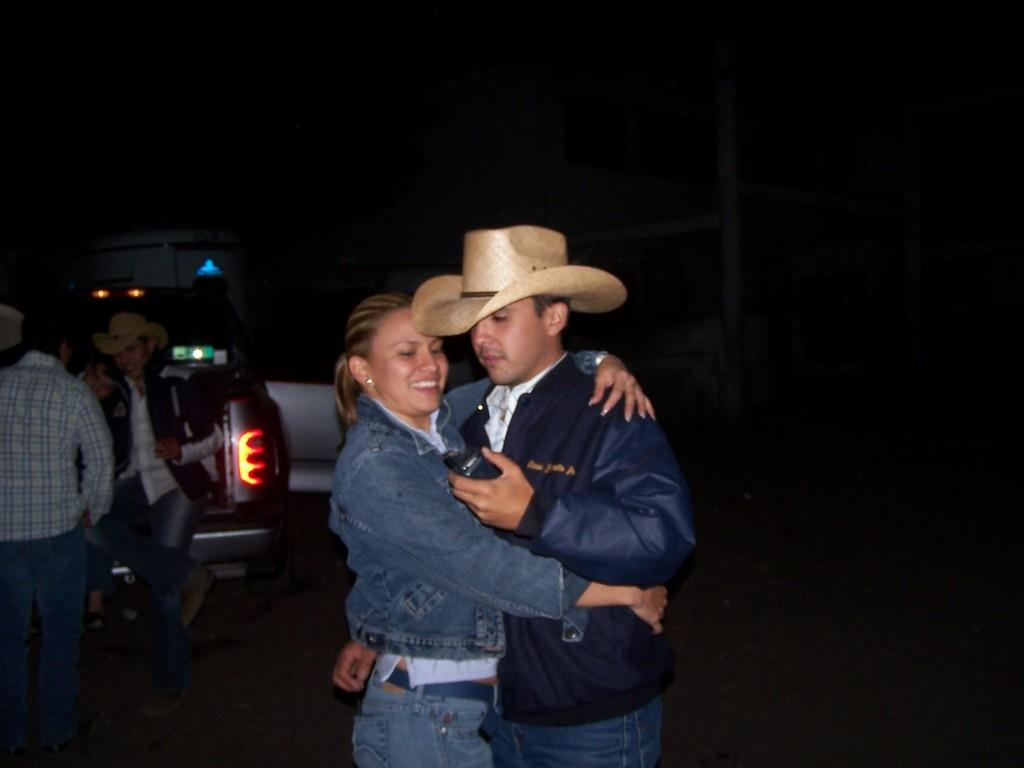What is the main subject in the middle of the picture? There is a couple in the middle of the picture. What else can be seen on the right side of the picture? There are people and a vehicle on the right side of the picture. How would you describe the overall lighting in the image? The background of the image is dark. What type of silver object can be seen on the ground in the image? There is no silver object present on the ground in the image. 